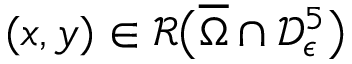Convert formula to latex. <formula><loc_0><loc_0><loc_500><loc_500>( x , y ) \in \mathcal { R } \left ( \overline { \Omega } \cap \mathcal { D } _ { \epsilon } ^ { 5 } \right )</formula> 